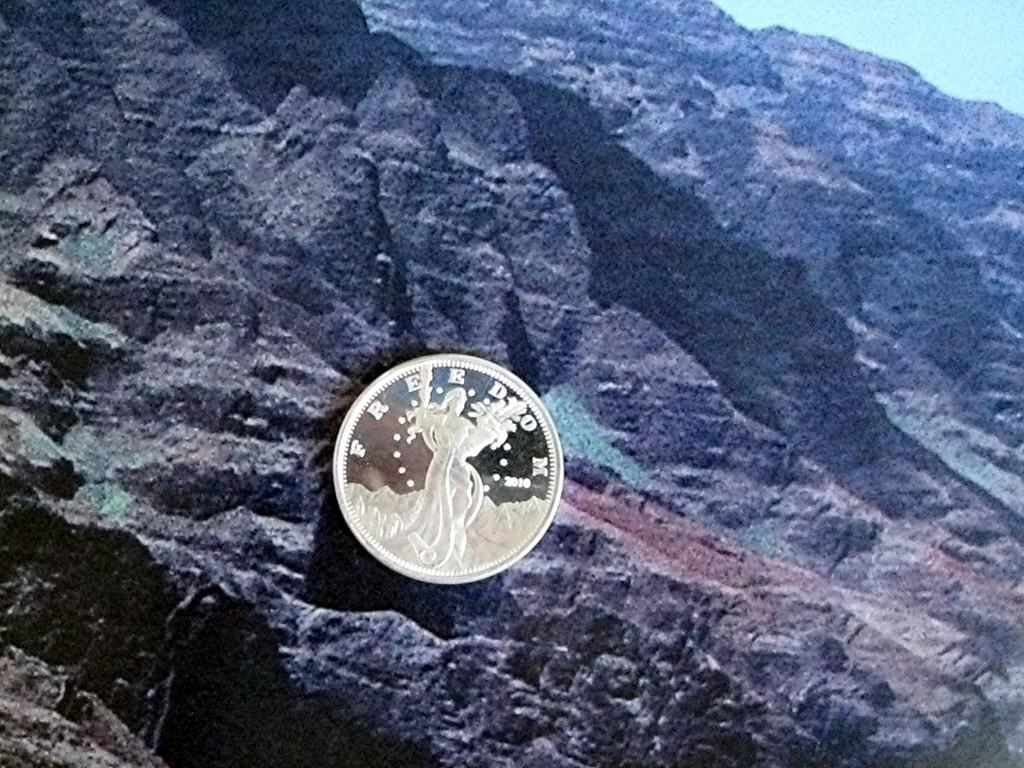<image>
Offer a succinct explanation of the picture presented. Freedom 2010 is etched into the face of this shiny coin. 